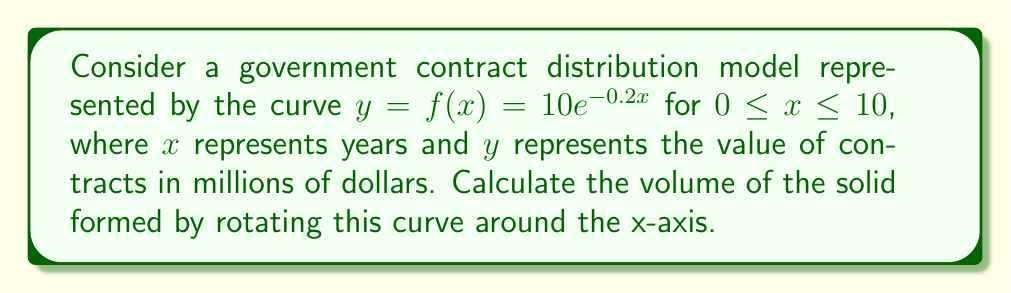Help me with this question. To solve this problem, we'll use the method of shells for volumes of revolution:

1) The formula for the volume using the method of shells is:
   $$V = 2\pi \int_{0}^{10} y \cdot x \, dx$$

2) Substitute the given function $f(x) = 10e^{-0.2x}$ into the formula:
   $$V = 2\pi \int_{0}^{10} 10e^{-0.2x} \cdot x \, dx$$

3) Simplify the constant:
   $$V = 20\pi \int_{0}^{10} xe^{-0.2x} \, dx$$

4) To integrate this, we need to use integration by parts. Let $u = x$ and $dv = e^{-0.2x}dx$:
   $$V = 20\pi \left[-5xe^{-0.2x}\right]_{0}^{10} + 20\pi \int_{0}^{10} 5e^{-0.2x} \, dx$$

5) Evaluate the first part and integrate the second part:
   $$V = 20\pi \left[-5xe^{-0.2x}\right]_{0}^{10} + 20\pi \left[-25e^{-0.2x}\right]_{0}^{10}$$

6) Substitute the limits:
   $$V = 20\pi \left[(-50e^{-2}) - (0)\right] + 20\pi \left[(-25e^{-2}) - (-25)\right]$$

7) Simplify:
   $$V = 20\pi \left[-50e^{-2} - 25e^{-2} + 25\right]$$
   $$V = 20\pi \left[25 - 75e^{-2}\right]$$

8) Calculate the final result:
   $$V \approx 1413.75$$
Answer: $1413.75$ cubic million dollars 